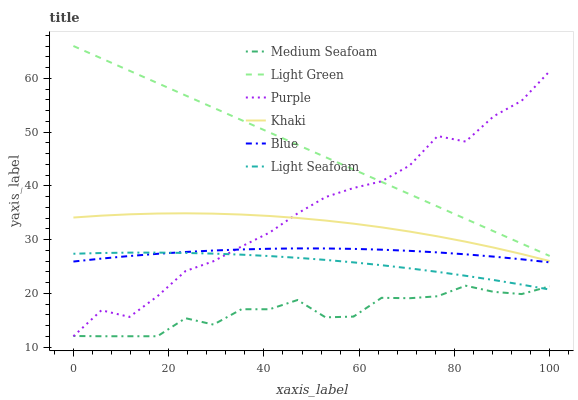Does Medium Seafoam have the minimum area under the curve?
Answer yes or no. Yes. Does Light Green have the maximum area under the curve?
Answer yes or no. Yes. Does Khaki have the minimum area under the curve?
Answer yes or no. No. Does Khaki have the maximum area under the curve?
Answer yes or no. No. Is Light Green the smoothest?
Answer yes or no. Yes. Is Purple the roughest?
Answer yes or no. Yes. Is Khaki the smoothest?
Answer yes or no. No. Is Khaki the roughest?
Answer yes or no. No. Does Purple have the lowest value?
Answer yes or no. Yes. Does Khaki have the lowest value?
Answer yes or no. No. Does Light Green have the highest value?
Answer yes or no. Yes. Does Khaki have the highest value?
Answer yes or no. No. Is Medium Seafoam less than Light Green?
Answer yes or no. Yes. Is Khaki greater than Blue?
Answer yes or no. Yes. Does Light Seafoam intersect Blue?
Answer yes or no. Yes. Is Light Seafoam less than Blue?
Answer yes or no. No. Is Light Seafoam greater than Blue?
Answer yes or no. No. Does Medium Seafoam intersect Light Green?
Answer yes or no. No. 